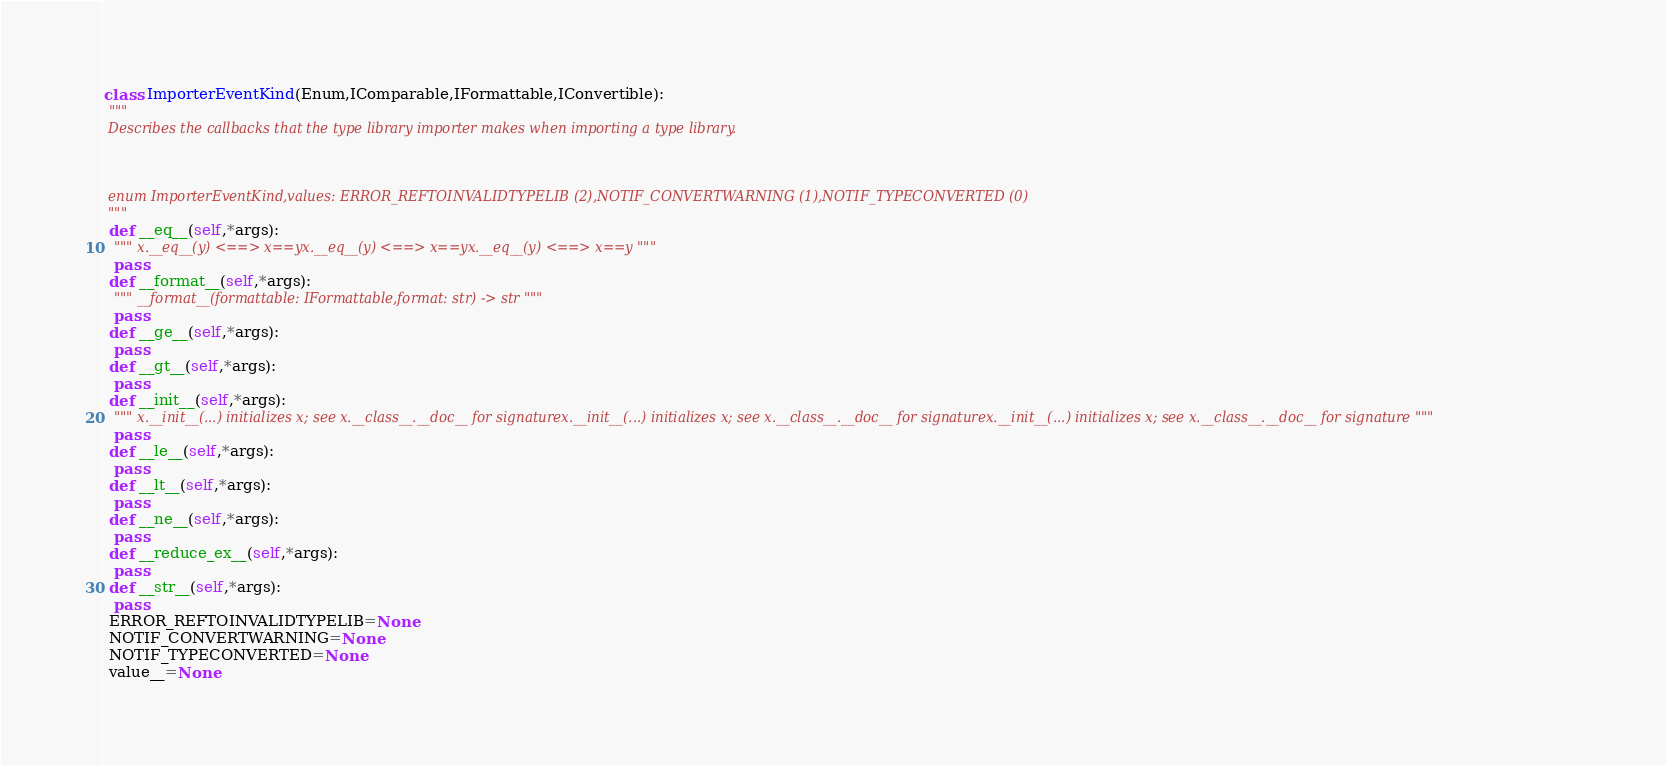<code> <loc_0><loc_0><loc_500><loc_500><_Python_>class ImporterEventKind(Enum,IComparable,IFormattable,IConvertible):
 """
 Describes the callbacks that the type library importer makes when importing a type library.

 

 enum ImporterEventKind,values: ERROR_REFTOINVALIDTYPELIB (2),NOTIF_CONVERTWARNING (1),NOTIF_TYPECONVERTED (0)
 """
 def __eq__(self,*args):
  """ x.__eq__(y) <==> x==yx.__eq__(y) <==> x==yx.__eq__(y) <==> x==y """
  pass
 def __format__(self,*args):
  """ __format__(formattable: IFormattable,format: str) -> str """
  pass
 def __ge__(self,*args):
  pass
 def __gt__(self,*args):
  pass
 def __init__(self,*args):
  """ x.__init__(...) initializes x; see x.__class__.__doc__ for signaturex.__init__(...) initializes x; see x.__class__.__doc__ for signaturex.__init__(...) initializes x; see x.__class__.__doc__ for signature """
  pass
 def __le__(self,*args):
  pass
 def __lt__(self,*args):
  pass
 def __ne__(self,*args):
  pass
 def __reduce_ex__(self,*args):
  pass
 def __str__(self,*args):
  pass
 ERROR_REFTOINVALIDTYPELIB=None
 NOTIF_CONVERTWARNING=None
 NOTIF_TYPECONVERTED=None
 value__=None

</code> 